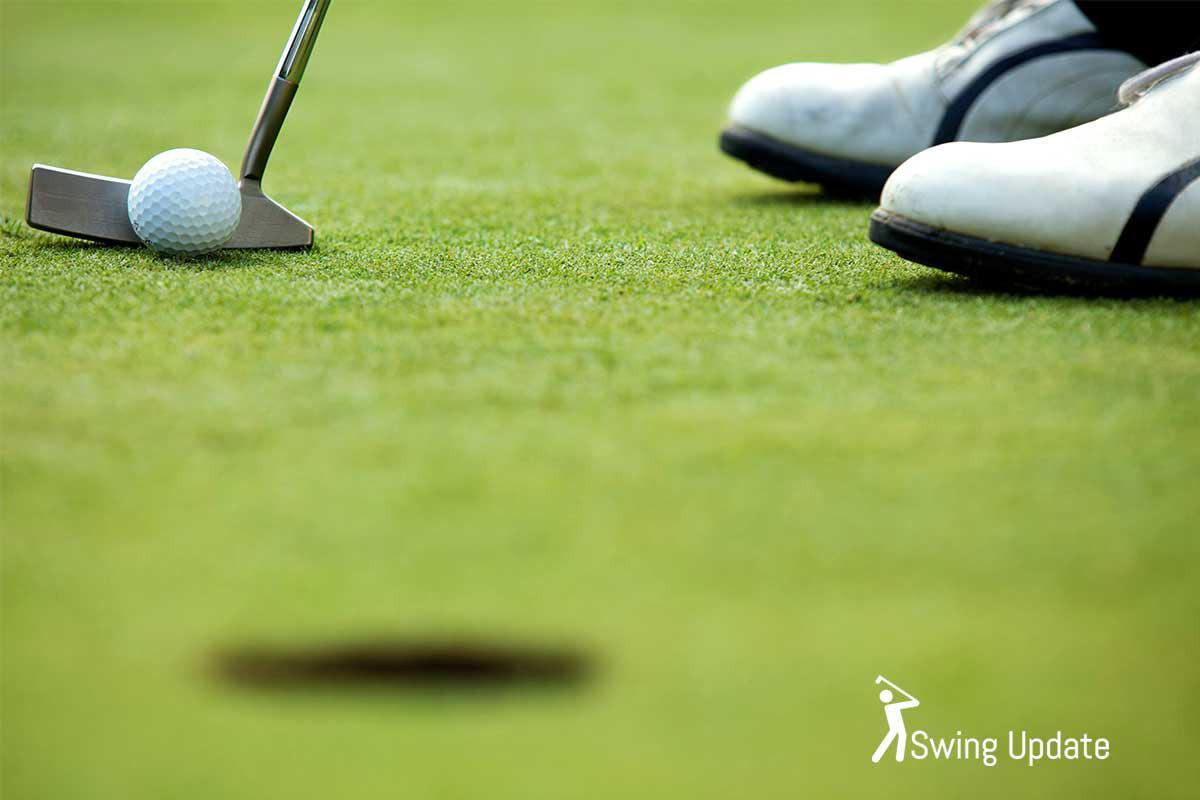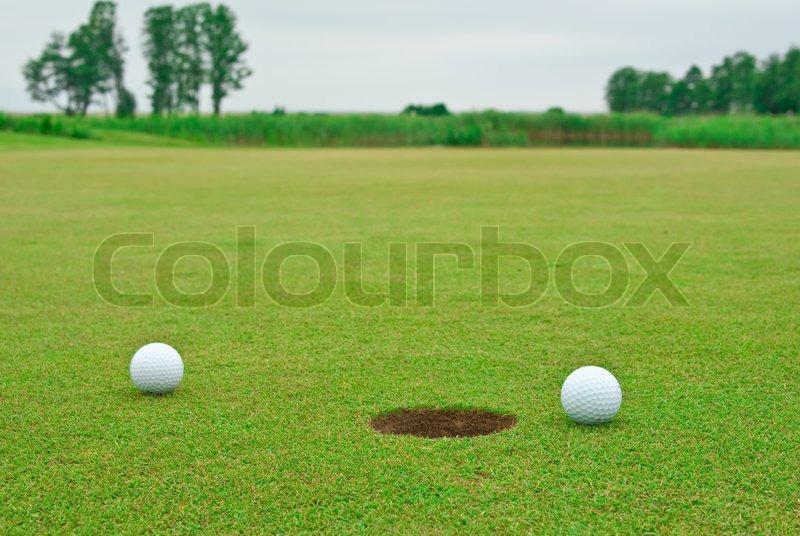The first image is the image on the left, the second image is the image on the right. For the images shown, is this caption "At least one image includes a ball on a golf tee." true? Answer yes or no. No. The first image is the image on the left, the second image is the image on the right. Given the left and right images, does the statement "There are two balls near the hole in one of the images." hold true? Answer yes or no. Yes. 